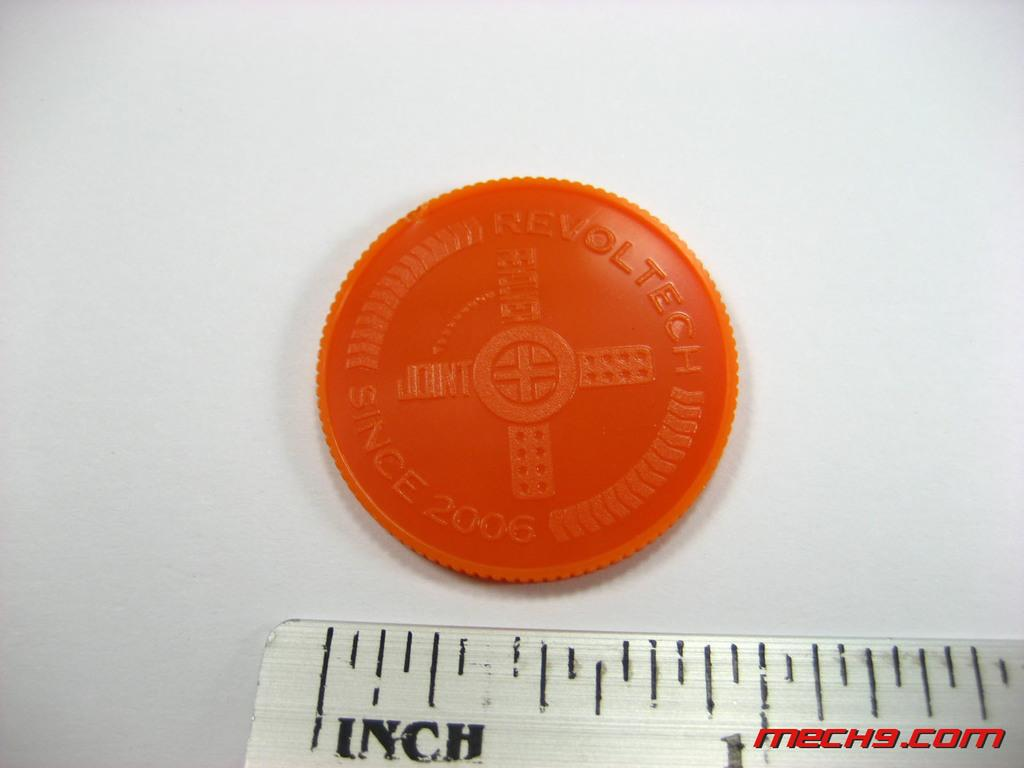<image>
Summarize the visual content of the image. the end of a ruler with the word 'mech9.com' at the bottom right of the photo 